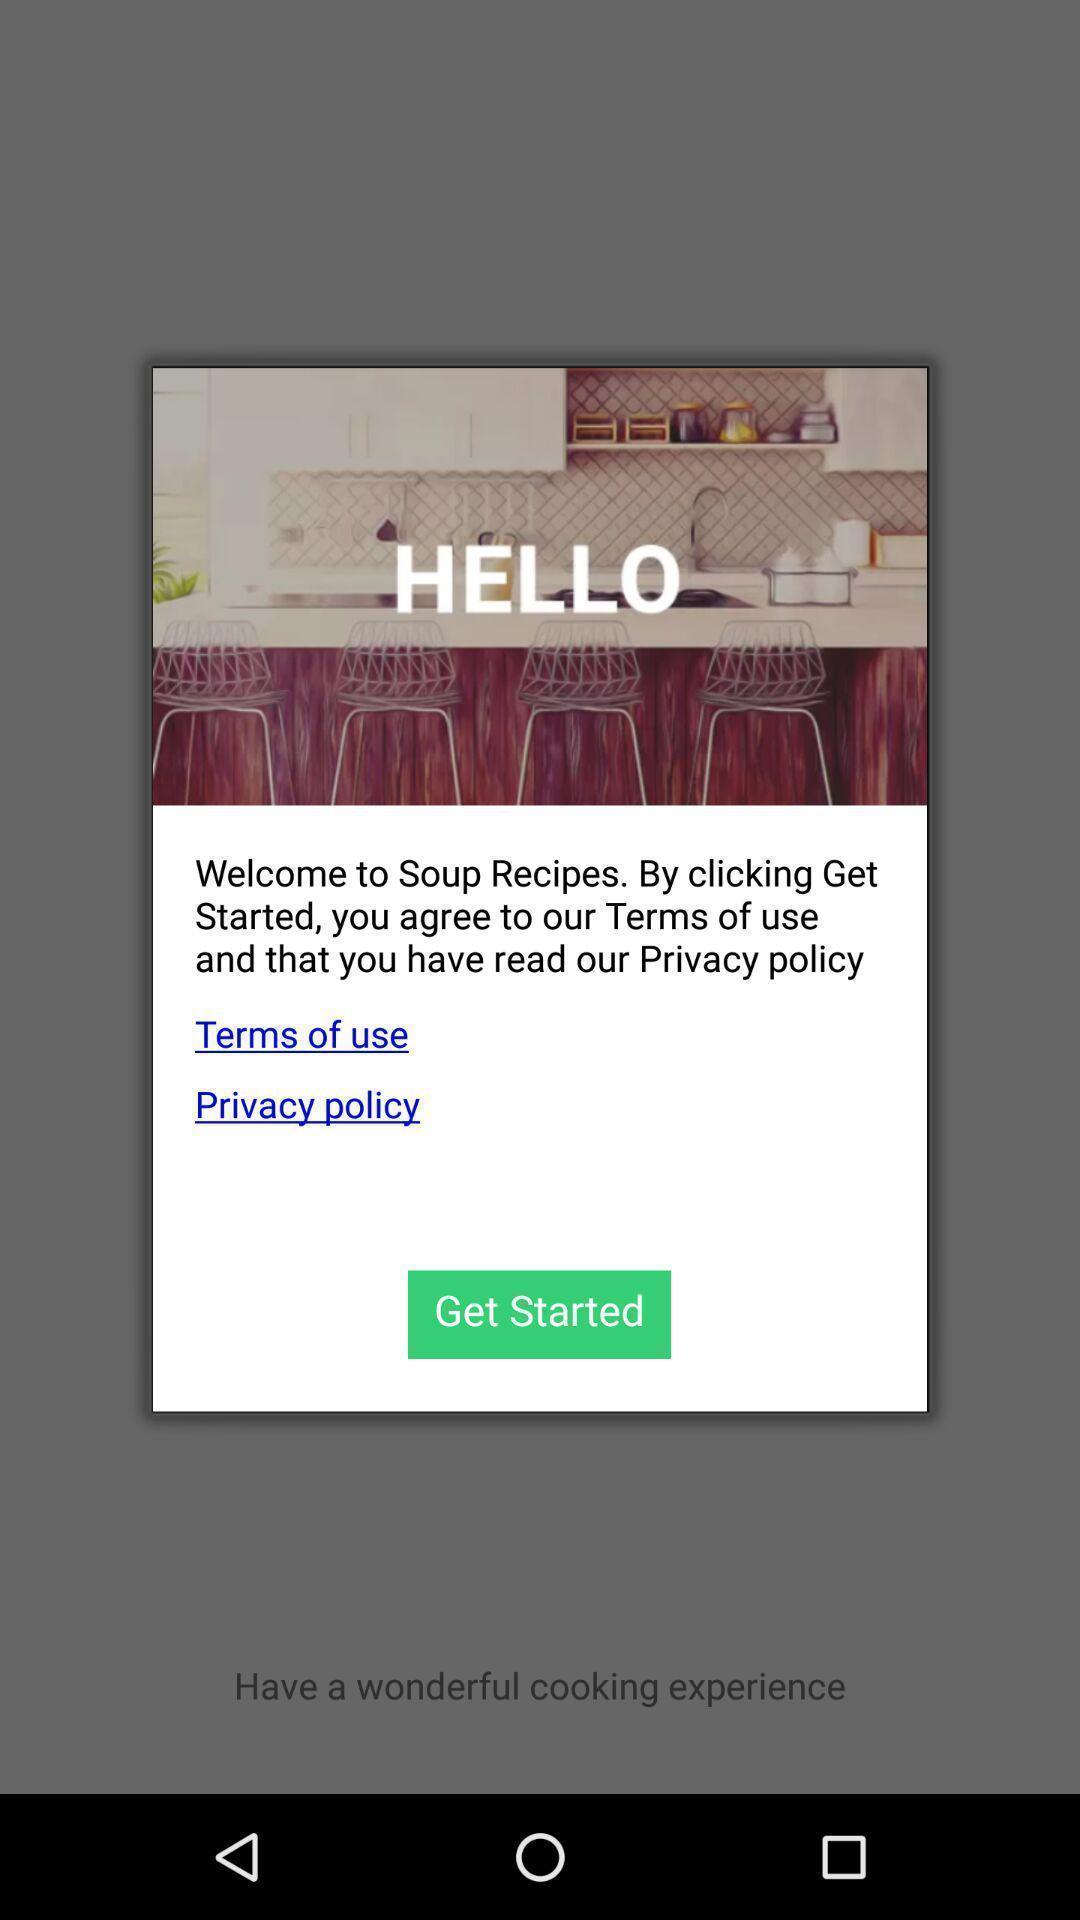Explain the elements present in this screenshot. Welcome page of social app. 